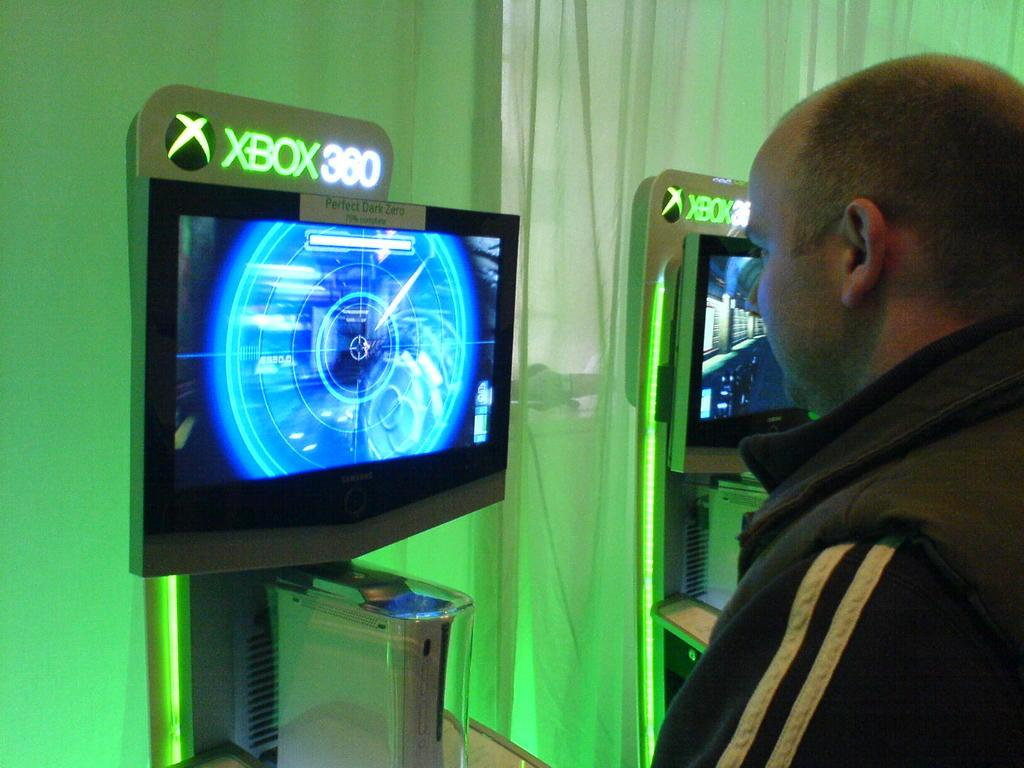Provide a one-sentence caption for the provided image. A display screen for the XBOX 360 with the game Perfect Dark Zero. 